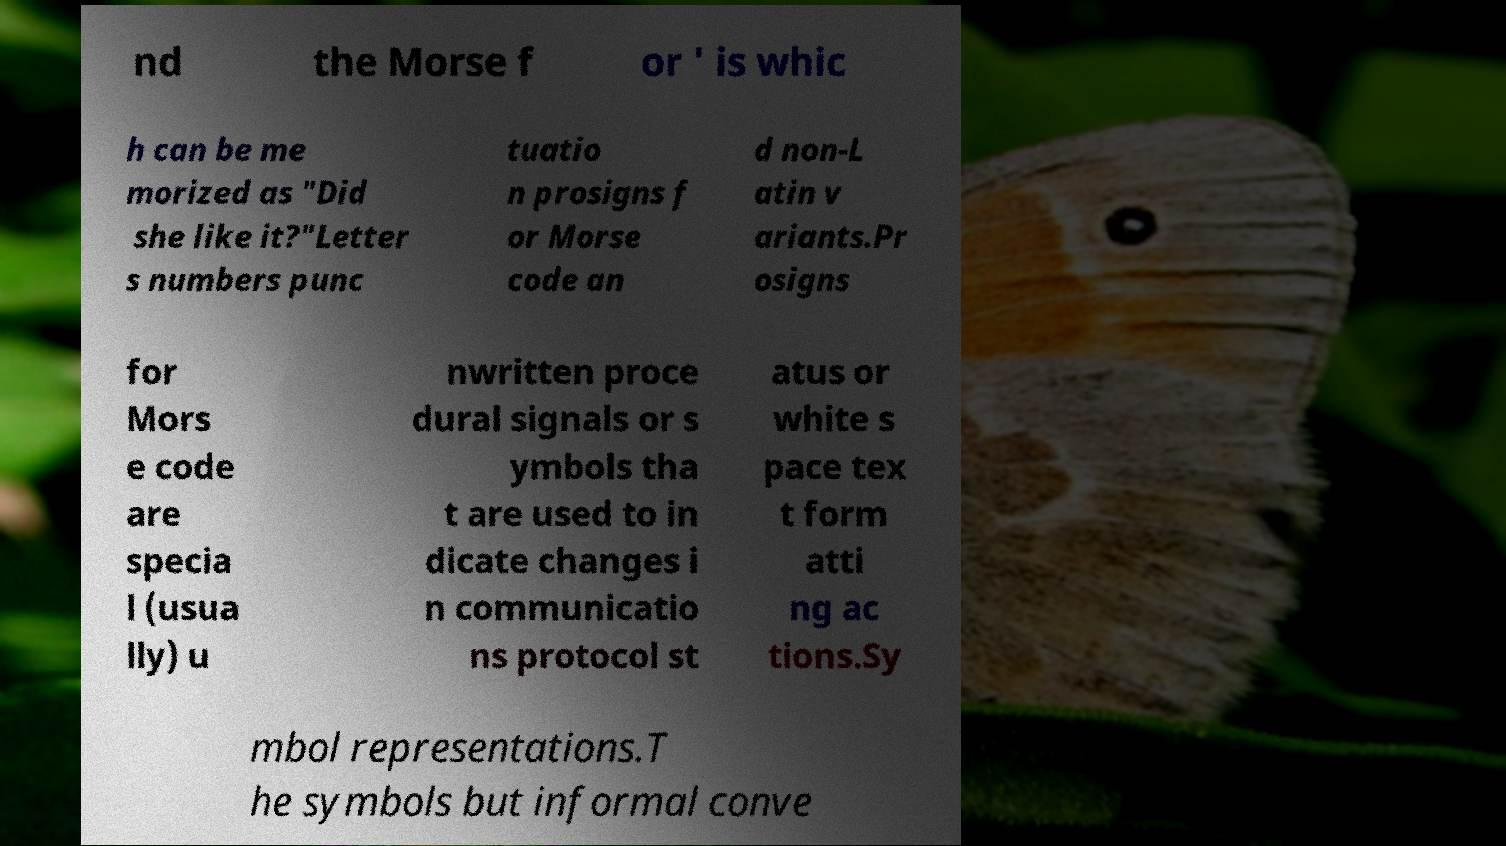What messages or text are displayed in this image? I need them in a readable, typed format. nd the Morse f or ' is whic h can be me morized as "Did she like it?"Letter s numbers punc tuatio n prosigns f or Morse code an d non-L atin v ariants.Pr osigns for Mors e code are specia l (usua lly) u nwritten proce dural signals or s ymbols tha t are used to in dicate changes i n communicatio ns protocol st atus or white s pace tex t form atti ng ac tions.Sy mbol representations.T he symbols but informal conve 